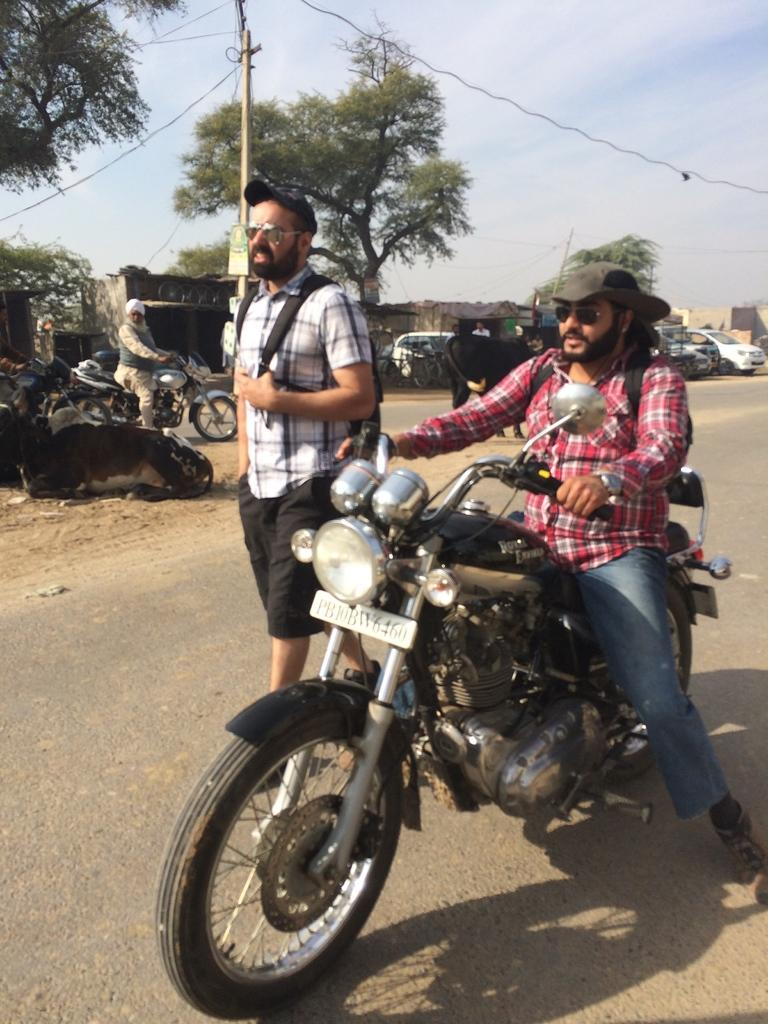What is the main action of the person in the image? There is a person standing in the image, and another person is sitting and riding a bike. What are the standing person and the sitting person wearing? Both the standing person and the sitting person are wearing a bag and a cap. Can you describe the background of the image? In the background, there is a house, cars on the road, trees, the sky, and a pole. What type of key is the person holding in the image? There is no key visible in the image. What is the person using to write on the paper in the image? There is no paper or writing instrument present in the image. 